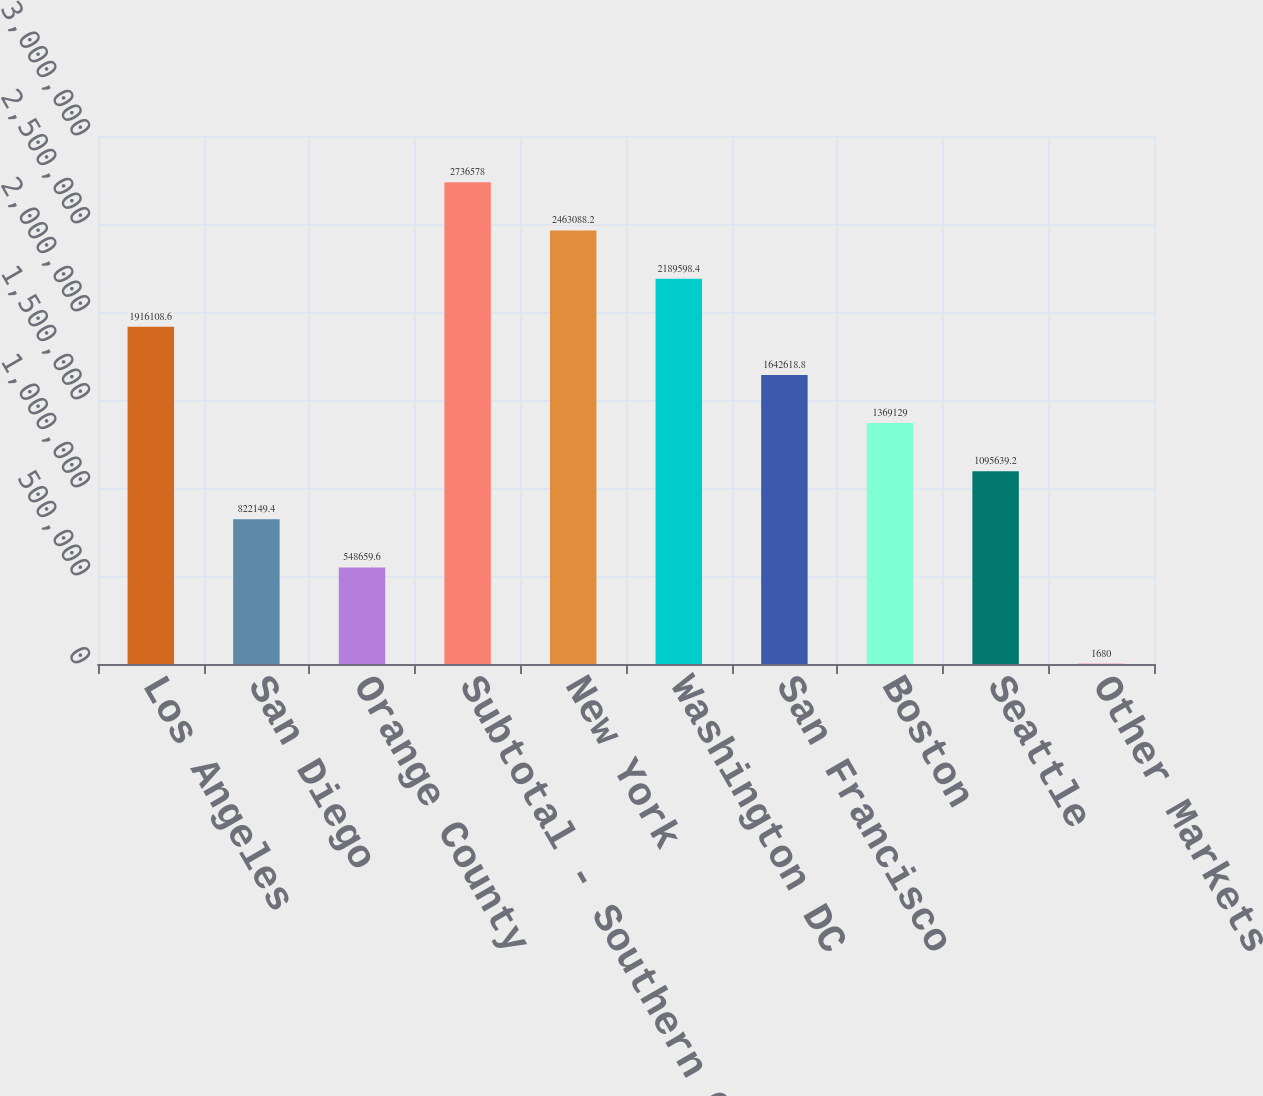<chart> <loc_0><loc_0><loc_500><loc_500><bar_chart><fcel>Los Angeles<fcel>San Diego<fcel>Orange County<fcel>Subtotal - Southern California<fcel>New York<fcel>Washington DC<fcel>San Francisco<fcel>Boston<fcel>Seattle<fcel>Other Markets<nl><fcel>1.91611e+06<fcel>822149<fcel>548660<fcel>2.73658e+06<fcel>2.46309e+06<fcel>2.1896e+06<fcel>1.64262e+06<fcel>1.36913e+06<fcel>1.09564e+06<fcel>1680<nl></chart> 